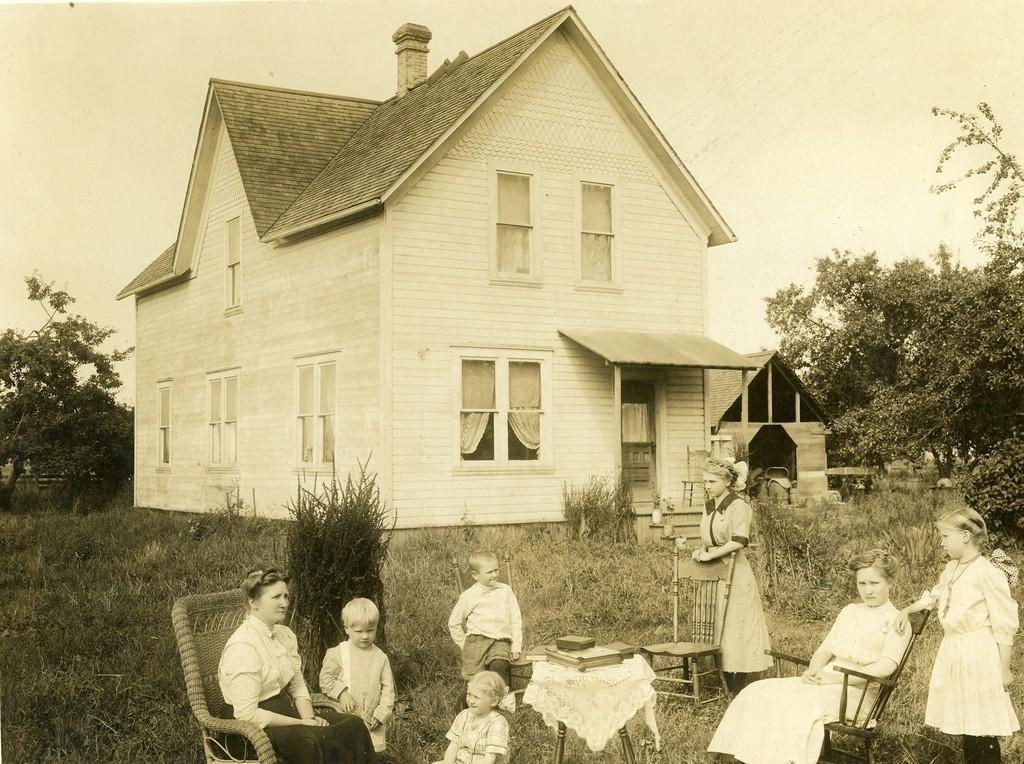Please provide a concise description of this image. In this picture I can see there are some people sitting here and there is a building in the backdrop. 